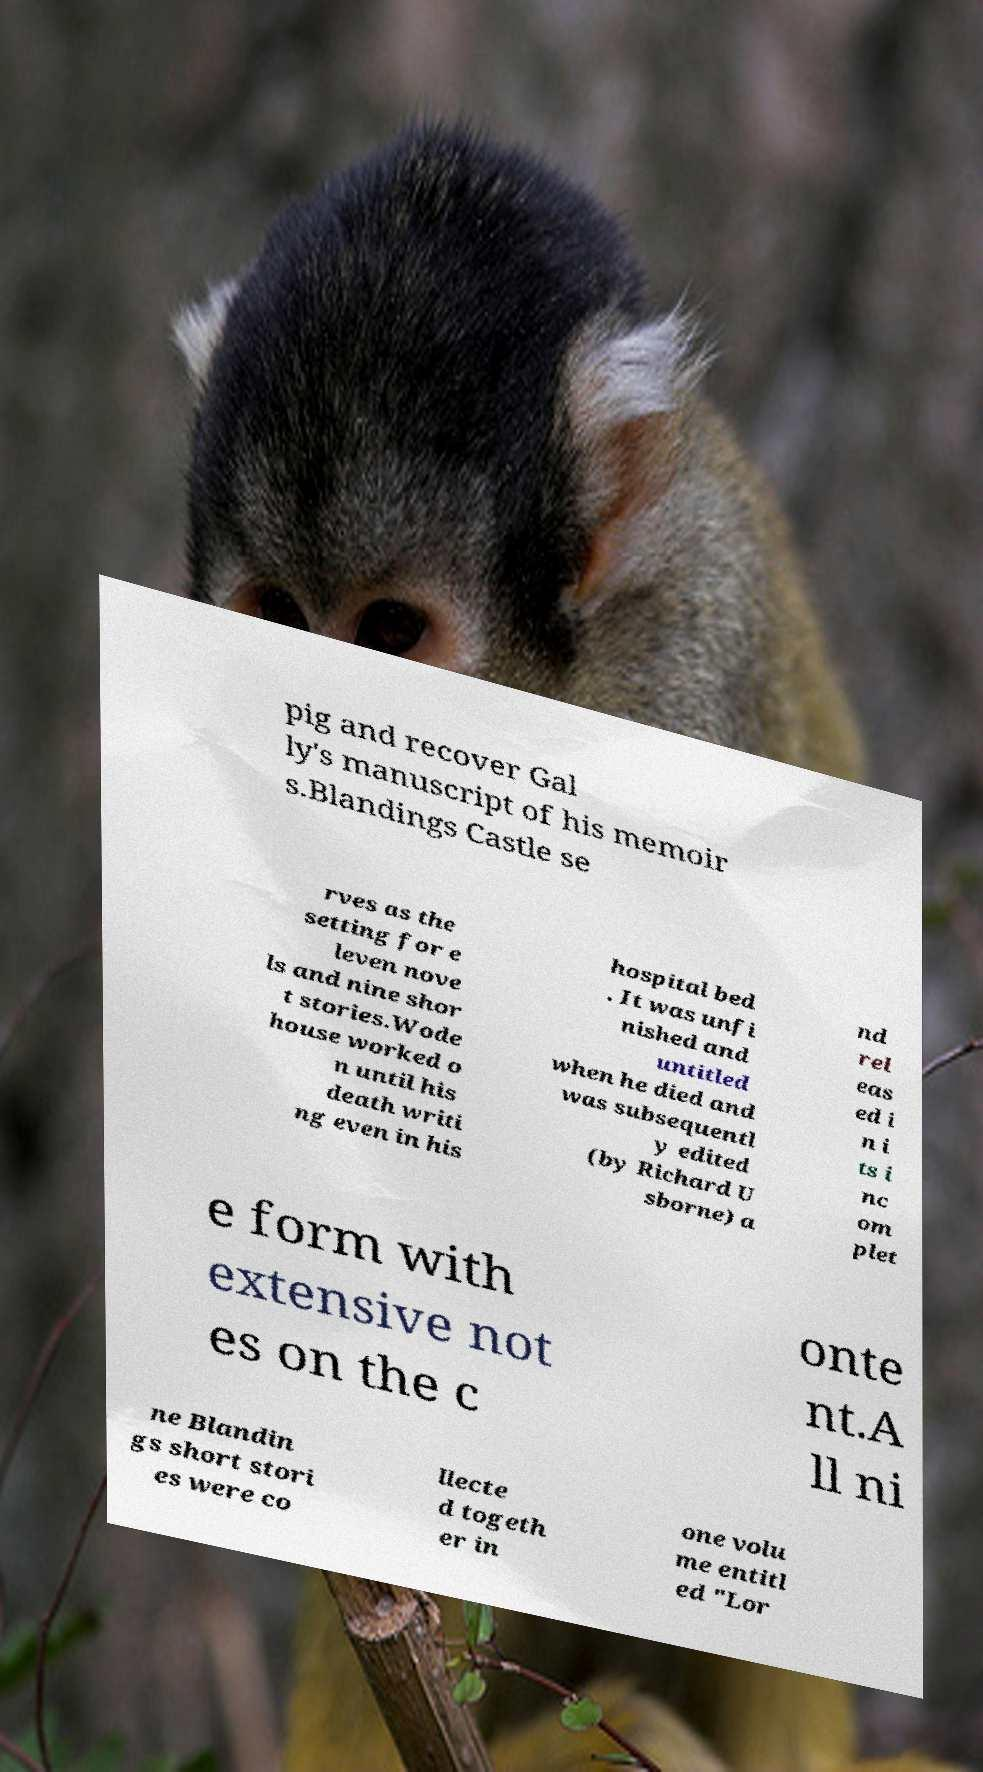I need the written content from this picture converted into text. Can you do that? pig and recover Gal ly's manuscript of his memoir s.Blandings Castle se rves as the setting for e leven nove ls and nine shor t stories.Wode house worked o n until his death writi ng even in his hospital bed . It was unfi nished and untitled when he died and was subsequentl y edited (by Richard U sborne) a nd rel eas ed i n i ts i nc om plet e form with extensive not es on the c onte nt.A ll ni ne Blandin gs short stori es were co llecte d togeth er in one volu me entitl ed "Lor 